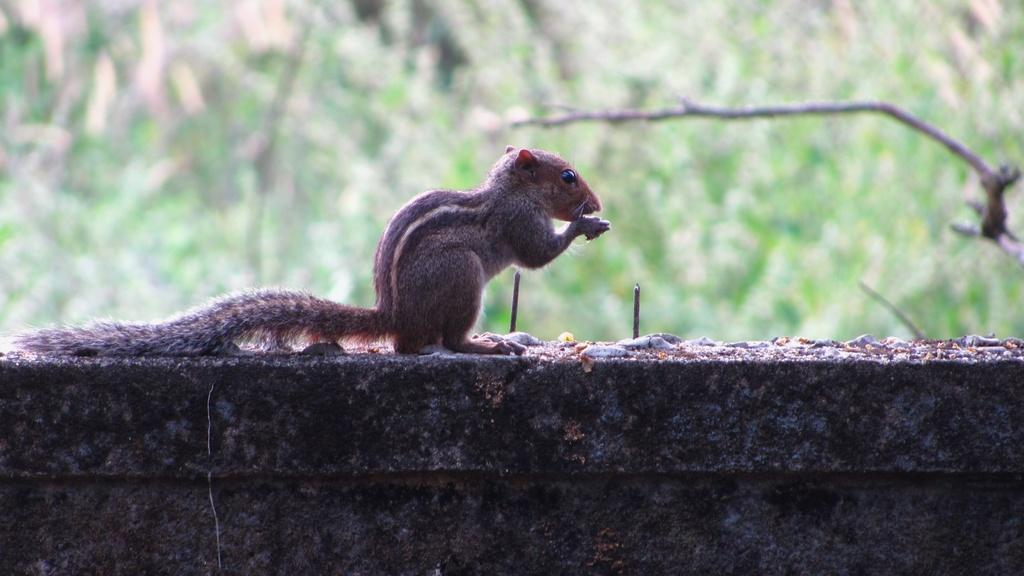What animal can be seen in the image? There is a squirrel in the image. Where is the squirrel located? The squirrel is sitting on a wall. What can be seen in the background of the image? There are trees visible in the background of the image. What type of drink is the squirrel holding in the image? There is no drink present in the image; the squirrel is sitting on a wall and there are trees visible in the background. 